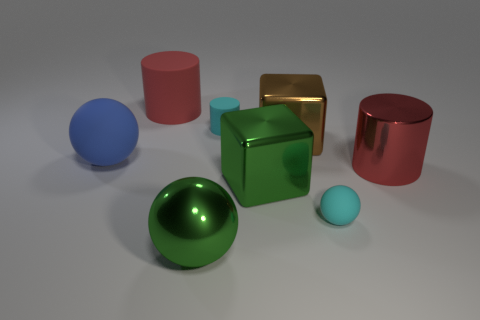What color is the large shiny sphere?
Offer a very short reply. Green. How many big purple blocks are there?
Your answer should be very brief. 0. What number of matte cylinders have the same color as the large shiny cylinder?
Give a very brief answer. 1. Do the tiny rubber thing behind the large rubber ball and the cyan matte object that is in front of the big blue object have the same shape?
Your answer should be very brief. No. There is a large block behind the green shiny thing on the right side of the tiny matte object that is on the left side of the tiny matte sphere; what color is it?
Provide a short and direct response. Brown. The big sphere in front of the big shiny cylinder is what color?
Your answer should be very brief. Green. What color is the cylinder that is the same size as the red matte thing?
Offer a terse response. Red. Does the blue thing have the same size as the green sphere?
Your answer should be compact. Yes. There is a small cyan cylinder; what number of balls are to the left of it?
Keep it short and to the point. 2. How many things are either cyan objects that are in front of the big shiny cylinder or big green cylinders?
Provide a short and direct response. 1. 